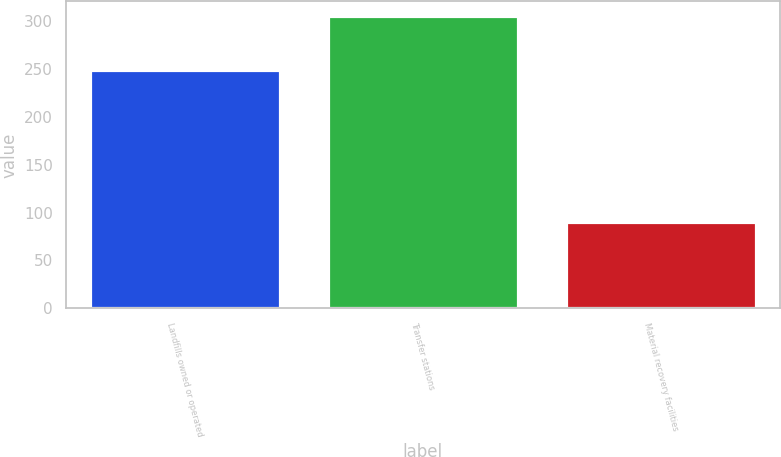Convert chart to OTSL. <chart><loc_0><loc_0><loc_500><loc_500><bar_chart><fcel>Landfills owned or operated<fcel>Transfer stations<fcel>Material recovery facilities<nl><fcel>249<fcel>305<fcel>90<nl></chart> 